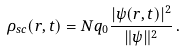Convert formula to latex. <formula><loc_0><loc_0><loc_500><loc_500>\rho _ { s c } ( r , t ) = N q _ { 0 } \frac { | \psi ( r , t ) | ^ { 2 } } { \| \psi \| ^ { 2 } } \, .</formula> 